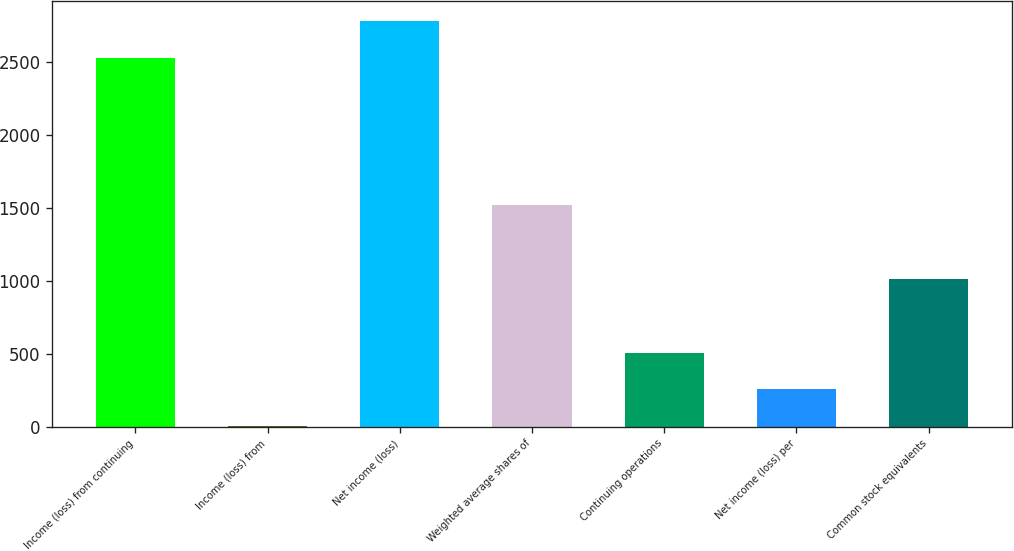<chart> <loc_0><loc_0><loc_500><loc_500><bar_chart><fcel>Income (loss) from continuing<fcel>Income (loss) from<fcel>Net income (loss)<fcel>Weighted average shares of<fcel>Continuing operations<fcel>Net income (loss) per<fcel>Common stock equivalents<nl><fcel>2528<fcel>2<fcel>2780.8<fcel>1518.8<fcel>507.6<fcel>254.8<fcel>1013.2<nl></chart> 